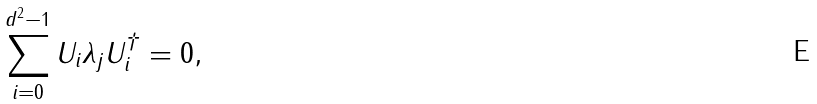Convert formula to latex. <formula><loc_0><loc_0><loc_500><loc_500>\sum _ { i = 0 } ^ { d ^ { 2 } - 1 } U _ { i } \lambda _ { j } U _ { i } ^ { \dagger } = 0 ,</formula> 